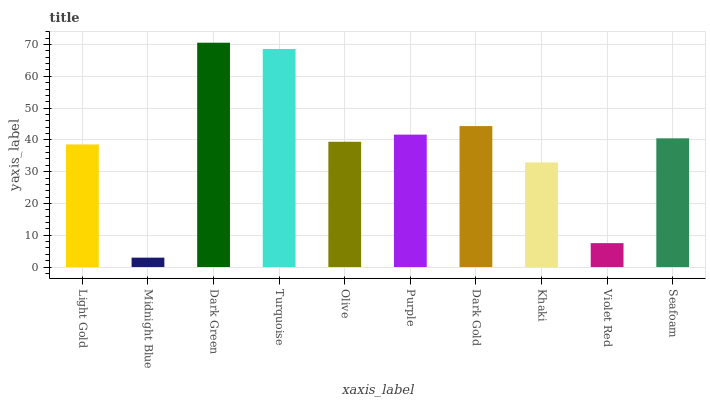Is Midnight Blue the minimum?
Answer yes or no. Yes. Is Dark Green the maximum?
Answer yes or no. Yes. Is Dark Green the minimum?
Answer yes or no. No. Is Midnight Blue the maximum?
Answer yes or no. No. Is Dark Green greater than Midnight Blue?
Answer yes or no. Yes. Is Midnight Blue less than Dark Green?
Answer yes or no. Yes. Is Midnight Blue greater than Dark Green?
Answer yes or no. No. Is Dark Green less than Midnight Blue?
Answer yes or no. No. Is Seafoam the high median?
Answer yes or no. Yes. Is Olive the low median?
Answer yes or no. Yes. Is Violet Red the high median?
Answer yes or no. No. Is Violet Red the low median?
Answer yes or no. No. 